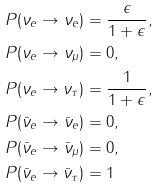Convert formula to latex. <formula><loc_0><loc_0><loc_500><loc_500>P ( \nu _ { e } \rightarrow \nu _ { e } ) & = \frac { \epsilon } { 1 + \epsilon } , \\ P ( \nu _ { e } \rightarrow \nu _ { \mu } ) & = 0 , \\ P ( \nu _ { e } \rightarrow \nu _ { \tau } ) & = \frac { 1 } { 1 + \epsilon } , \\ P ( \bar { \nu } _ { e } \rightarrow \bar { \nu } _ { e } ) & = 0 , \\ P ( \bar { \nu } _ { e } \rightarrow \bar { \nu } _ { \mu } ) & = 0 , \\ P ( \bar { \nu } _ { e } \rightarrow \bar { \nu } _ { \tau } ) & = 1</formula> 